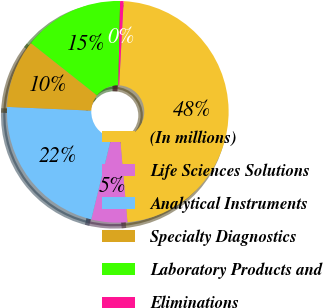Convert chart. <chart><loc_0><loc_0><loc_500><loc_500><pie_chart><fcel>(In millions)<fcel>Life Sciences Solutions<fcel>Analytical Instruments<fcel>Specialty Diagnostics<fcel>Laboratory Products and<fcel>Eliminations<nl><fcel>47.77%<fcel>5.23%<fcel>21.87%<fcel>9.95%<fcel>14.68%<fcel>0.5%<nl></chart> 